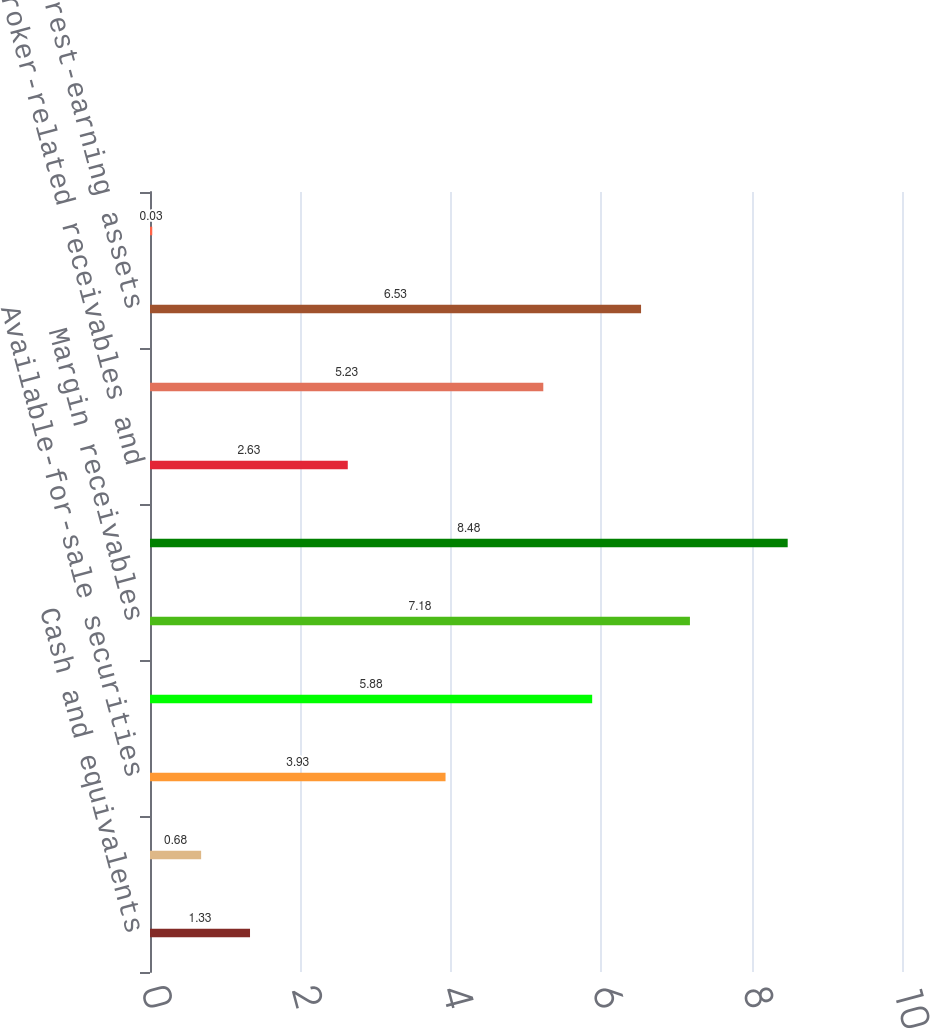<chart> <loc_0><loc_0><loc_500><loc_500><bar_chart><fcel>Cash and equivalents<fcel>Cash required to be segregated<fcel>Available-for-sale securities<fcel>Held-to-maturity securities<fcel>Margin receivables<fcel>Loans (2)<fcel>Broker-related receivables and<fcel>Subtotal interest-earning<fcel>Total interest-earning assets<fcel>Sweep deposits<nl><fcel>1.33<fcel>0.68<fcel>3.93<fcel>5.88<fcel>7.18<fcel>8.48<fcel>2.63<fcel>5.23<fcel>6.53<fcel>0.03<nl></chart> 